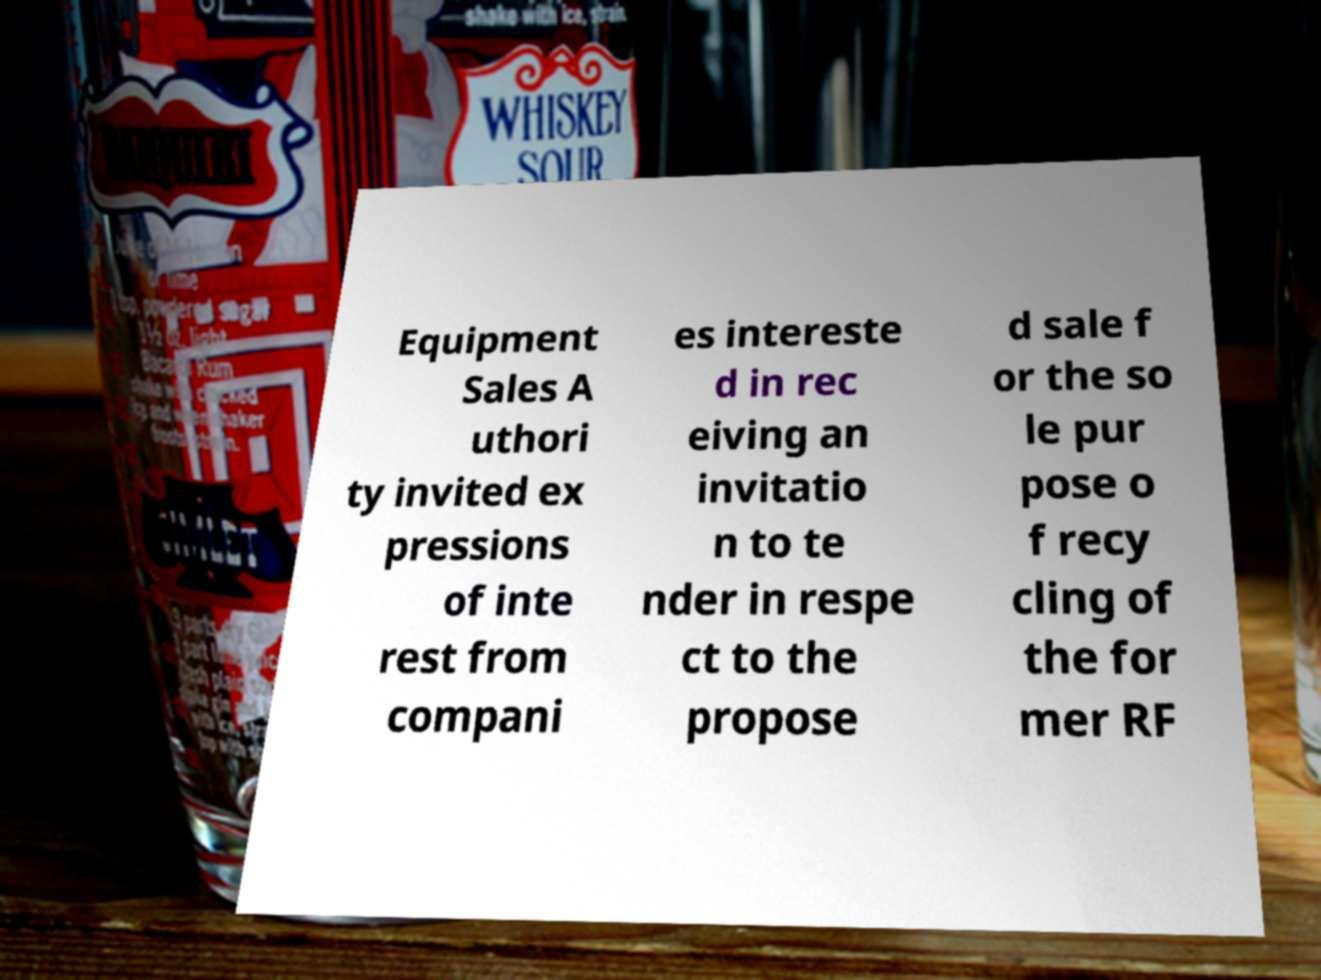I need the written content from this picture converted into text. Can you do that? Equipment Sales A uthori ty invited ex pressions of inte rest from compani es intereste d in rec eiving an invitatio n to te nder in respe ct to the propose d sale f or the so le pur pose o f recy cling of the for mer RF 